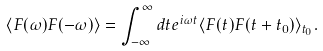<formula> <loc_0><loc_0><loc_500><loc_500>\langle F ( \omega ) F ( - \omega ) \rangle = \int _ { - \infty } ^ { \infty } d t e ^ { i \omega t } \langle F ( t ) F ( t + t _ { 0 } ) \rangle _ { t _ { 0 } } .</formula> 